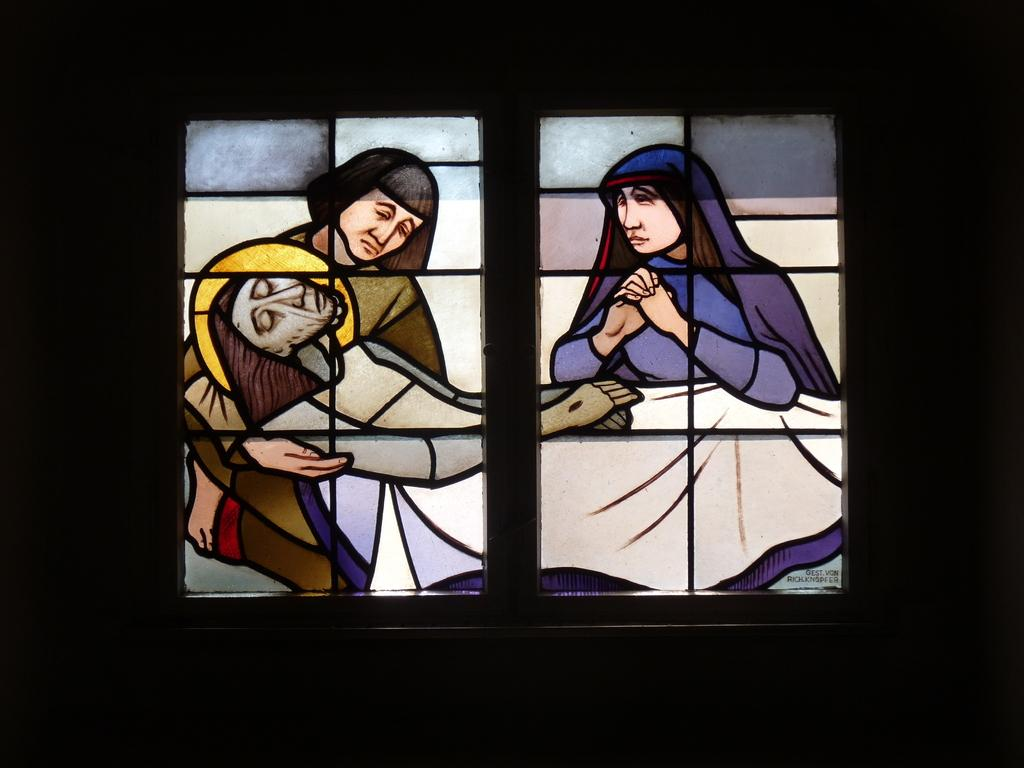What type of window is visible in the image? There is a glass window in the image. What is depicted on the glass window? The glass window has a crafted sketch painting on it. How many people are lying on the hand in the image? There are two women and a man lying on the hand in the image. What type of carpenter is depicted in the image? There is no carpenter present in the image. Can you tell me how many donkeys are lying on the hand in the image? There are no donkeys present in the image; it features two women and a man lying on the hand. 